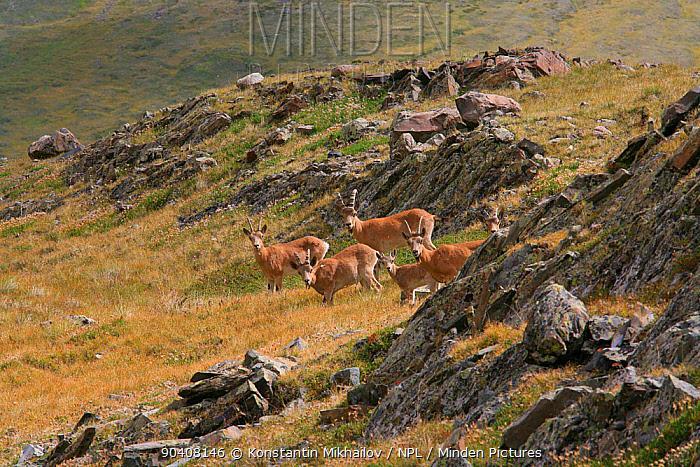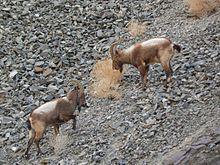The first image is the image on the left, the second image is the image on the right. Evaluate the accuracy of this statement regarding the images: "Right and left images contain the same number of hooved animals.". Is it true? Answer yes or no. No. 